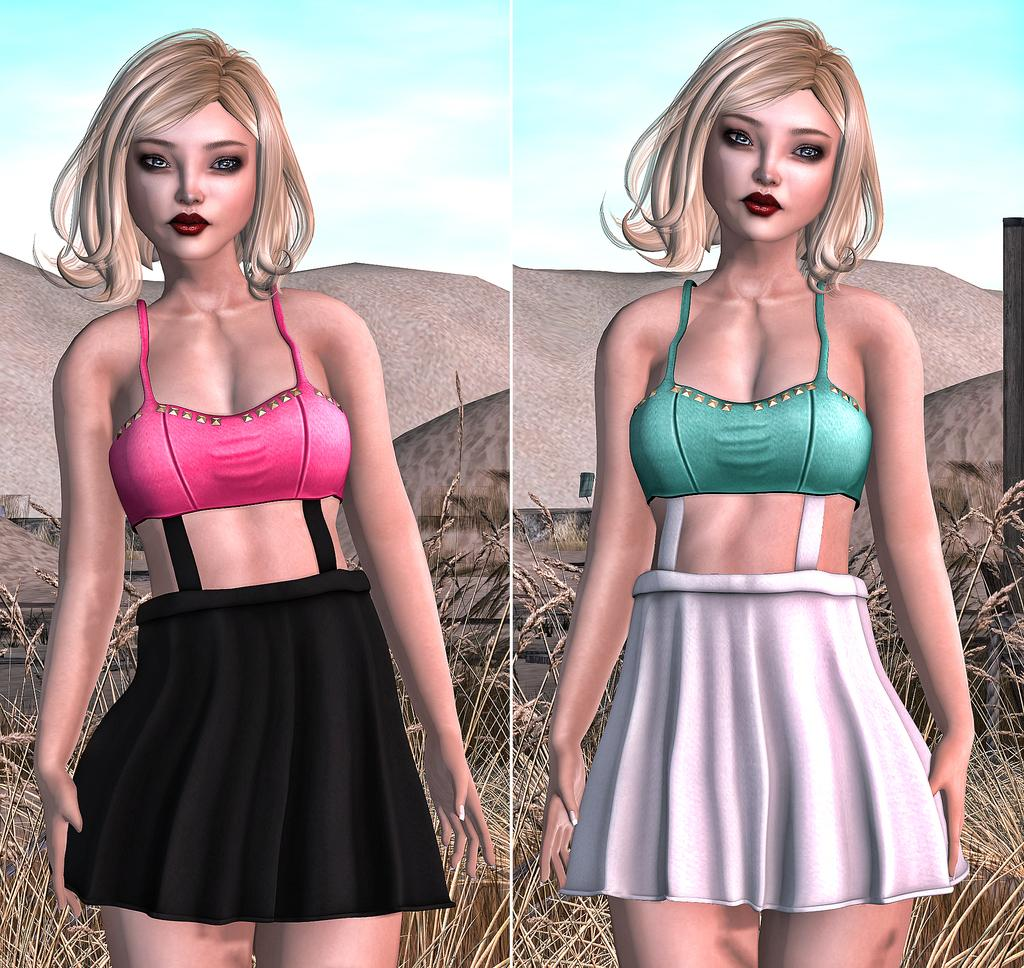What type of artwork is shown in the image? The image is a collage. What subjects are featured in the collage? There are pictures of women in the collage. What type of natural environment is depicted in the collage? Grass is depicted in the collage. What is visible in the sky in the collage? The sky with clouds is visible in the collage. How many pumpkins are present in the collage? There are no pumpkins depicted in the collage. What type of nail is used to hang the collage on the wall? The collage is not shown hanging on a wall, and therefore no nails are visible in the image. 